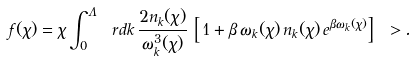<formula> <loc_0><loc_0><loc_500><loc_500>f ( \chi ) = \chi \int _ { 0 } ^ { \Lambda } \ r d k \, \frac { 2 n _ { k } ( \chi ) } { \omega _ { k } ^ { 3 } ( \chi ) } \, \left [ \, 1 + \beta \, \omega _ { k } ( \chi ) \, n _ { k } ( \chi ) \, e ^ { \beta \omega _ { k } ( \chi ) } \right ] \ > .</formula> 